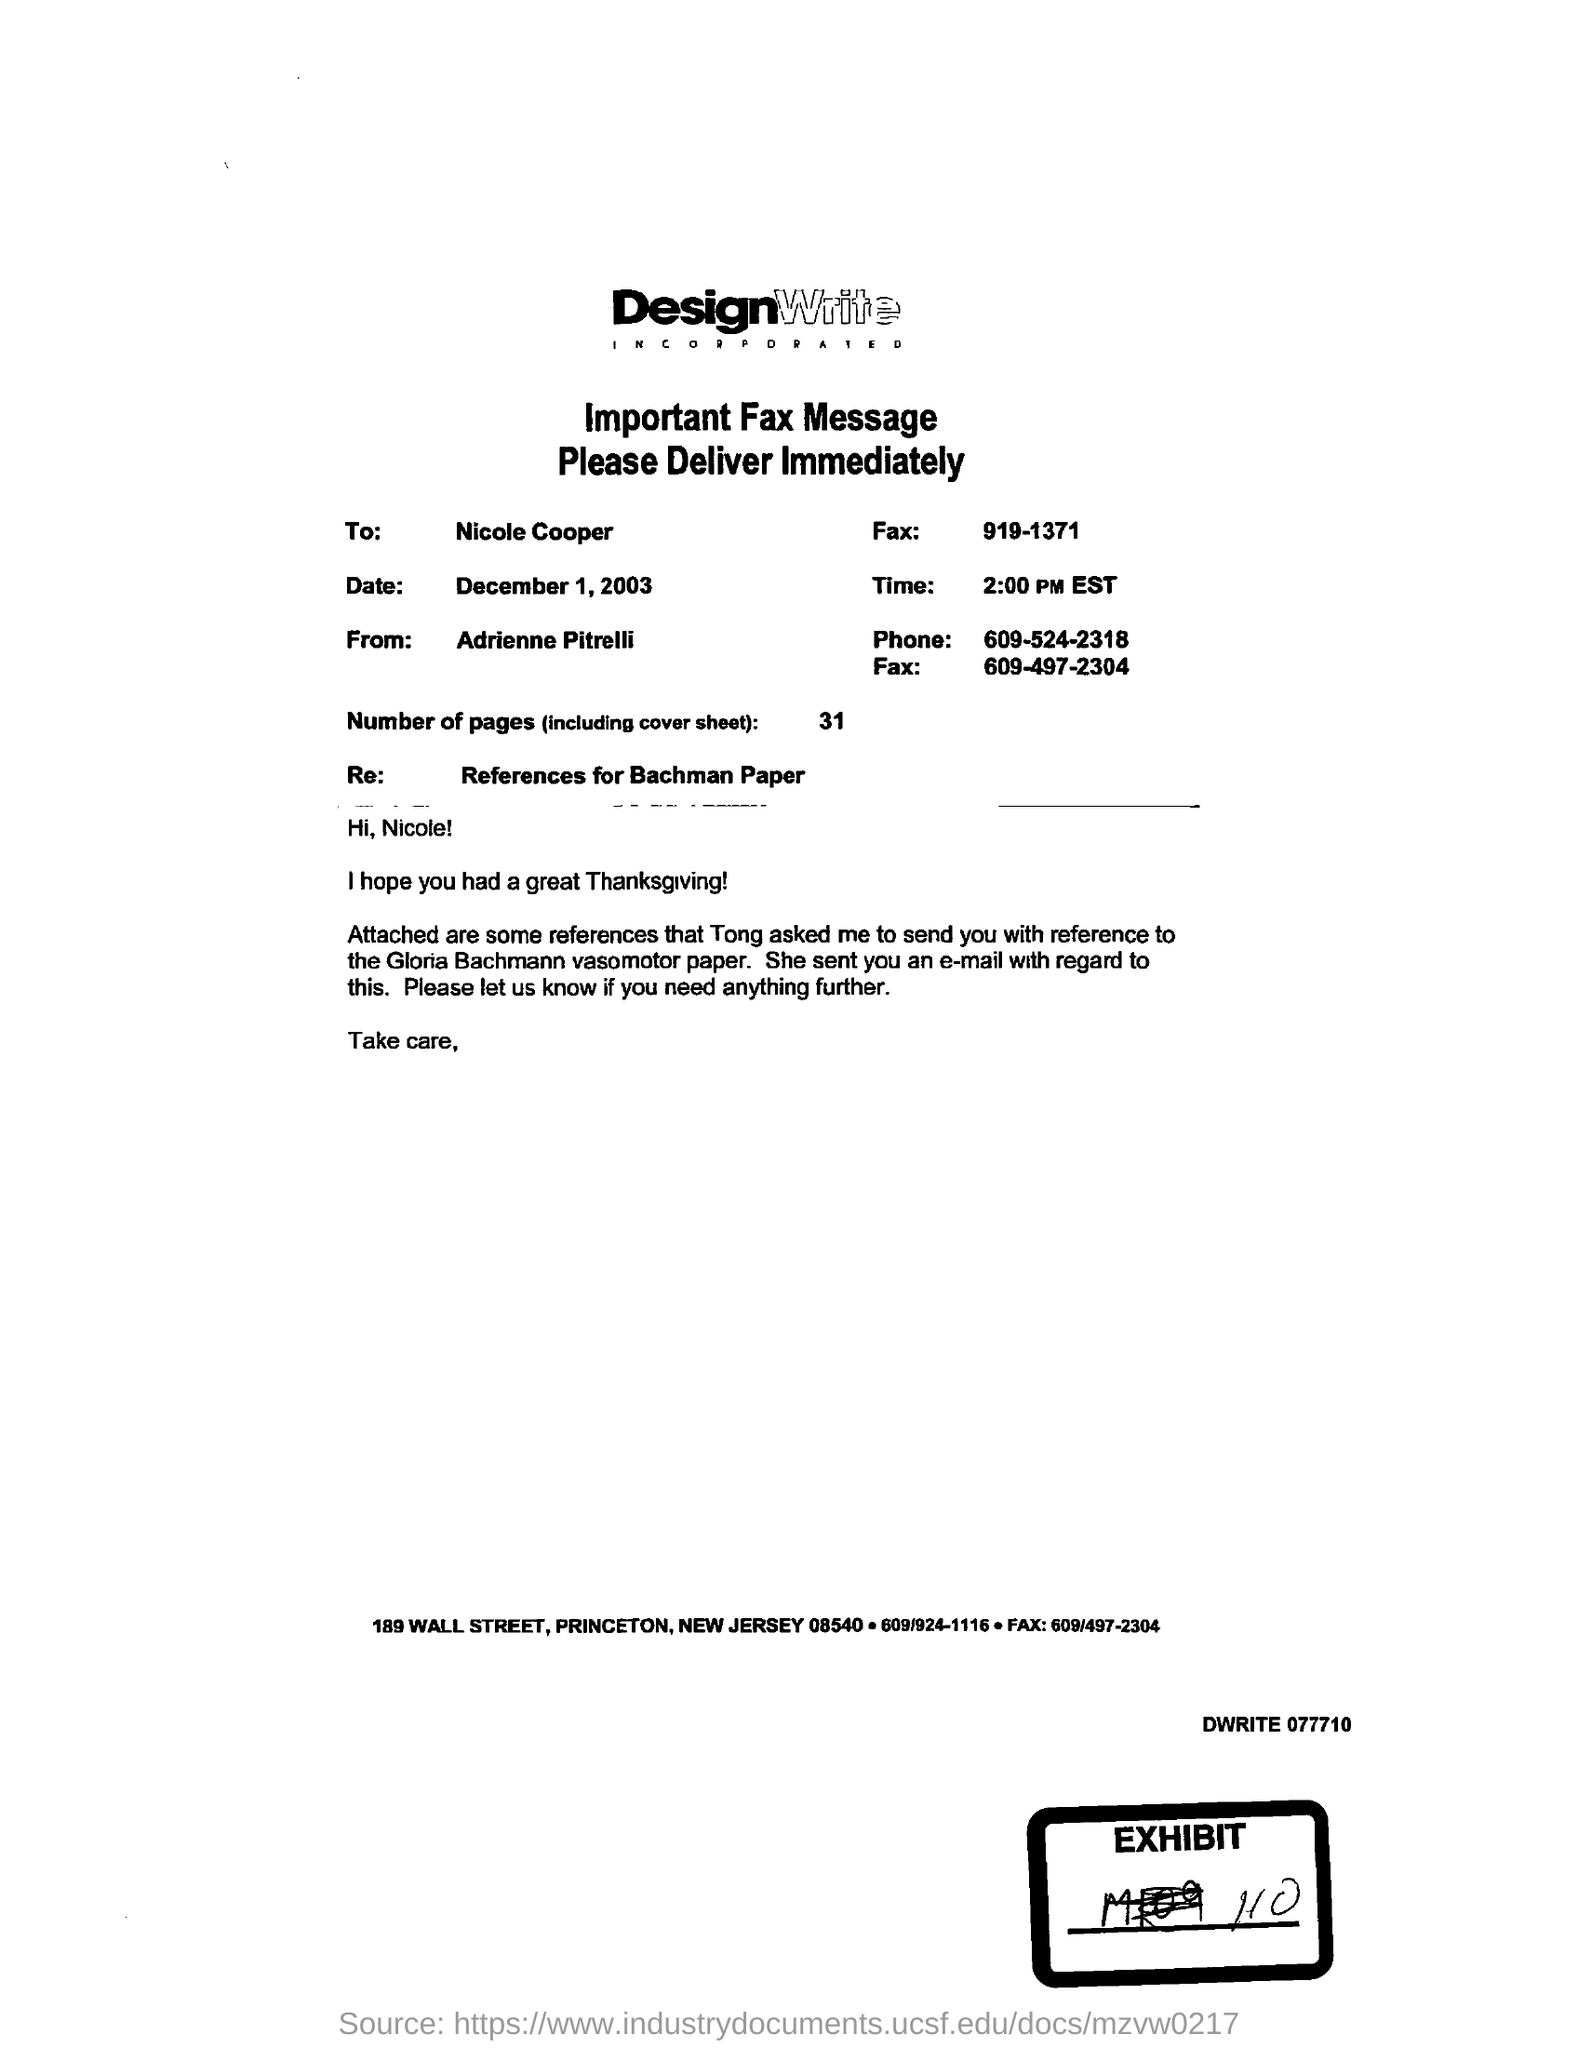What is the date?
Offer a terse response. December 1, 2003. What is the time?
Make the answer very short. 2:00 PM EST. What is the number of pages?
Provide a short and direct response. 31. What is the phone number?
Your answer should be compact. 609-524-2318. 